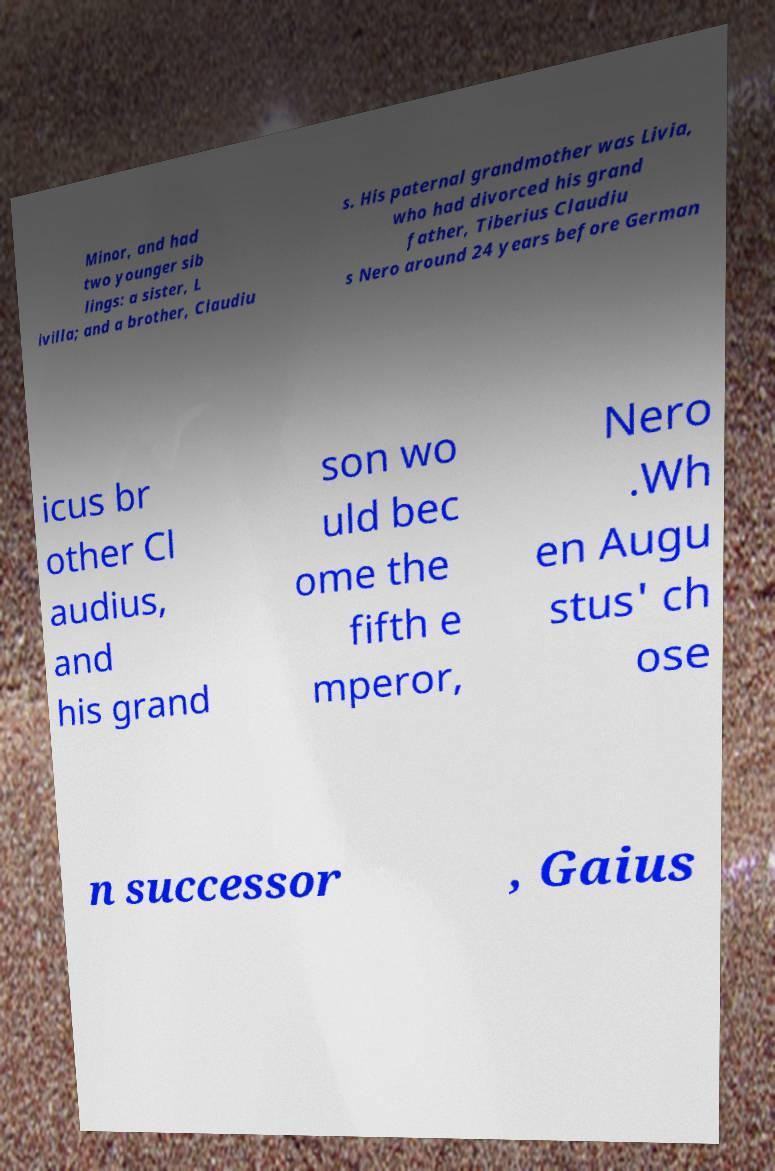Please identify and transcribe the text found in this image. Minor, and had two younger sib lings: a sister, L ivilla; and a brother, Claudiu s. His paternal grandmother was Livia, who had divorced his grand father, Tiberius Claudiu s Nero around 24 years before German icus br other Cl audius, and his grand son wo uld bec ome the fifth e mperor, Nero .Wh en Augu stus' ch ose n successor , Gaius 